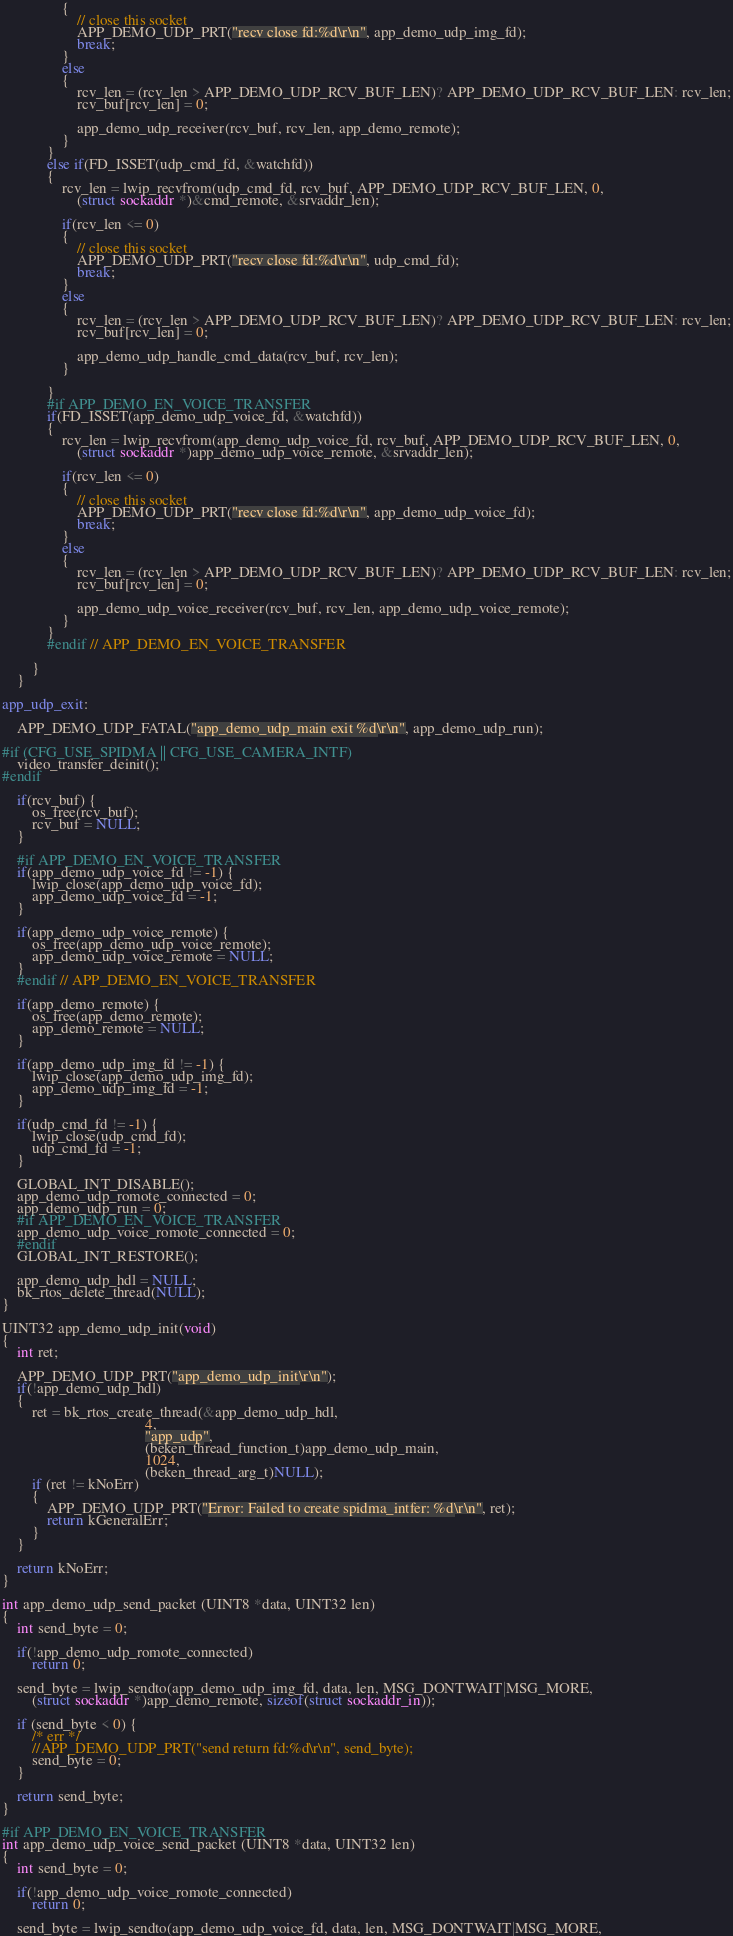Convert code to text. <code><loc_0><loc_0><loc_500><loc_500><_C_>                {
                    // close this socket
                    APP_DEMO_UDP_PRT("recv close fd:%d\r\n", app_demo_udp_img_fd);
                    break;
                } 
                else 
                {
                    rcv_len = (rcv_len > APP_DEMO_UDP_RCV_BUF_LEN)? APP_DEMO_UDP_RCV_BUF_LEN: rcv_len;
                    rcv_buf[rcv_len] = 0;

                    app_demo_udp_receiver(rcv_buf, rcv_len, app_demo_remote);
                }
            }
            else if(FD_ISSET(udp_cmd_fd, &watchfd)) 
            {
                rcv_len = lwip_recvfrom(udp_cmd_fd, rcv_buf, APP_DEMO_UDP_RCV_BUF_LEN, 0,
                    (struct sockaddr *)&cmd_remote, &srvaddr_len);
                
                if(rcv_len <= 0) 
                {
                    // close this socket
                    APP_DEMO_UDP_PRT("recv close fd:%d\r\n", udp_cmd_fd);
                    break;
                } 
                else 
                {
                    rcv_len = (rcv_len > APP_DEMO_UDP_RCV_BUF_LEN)? APP_DEMO_UDP_RCV_BUF_LEN: rcv_len;
                    rcv_buf[rcv_len] = 0;
                    
                    app_demo_udp_handle_cmd_data(rcv_buf, rcv_len);
                }

            }
            #if APP_DEMO_EN_VOICE_TRANSFER
            if(FD_ISSET(app_demo_udp_voice_fd, &watchfd)) 
            { 
                rcv_len = lwip_recvfrom(app_demo_udp_voice_fd, rcv_buf, APP_DEMO_UDP_RCV_BUF_LEN, 0,
                    (struct sockaddr *)app_demo_udp_voice_remote, &srvaddr_len);
                
                if(rcv_len <= 0) 
                {
                    // close this socket
                    APP_DEMO_UDP_PRT("recv close fd:%d\r\n", app_demo_udp_voice_fd);
                    break;
                } 
                else 
                {
                    rcv_len = (rcv_len > APP_DEMO_UDP_RCV_BUF_LEN)? APP_DEMO_UDP_RCV_BUF_LEN: rcv_len;
                    rcv_buf[rcv_len] = 0;

                    app_demo_udp_voice_receiver(rcv_buf, rcv_len, app_demo_udp_voice_remote);
                }
            }
            #endif // APP_DEMO_EN_VOICE_TRANSFER

        }
    }
	
app_udp_exit:
    
    APP_DEMO_UDP_FATAL("app_demo_udp_main exit %d\r\n", app_demo_udp_run);

#if (CFG_USE_SPIDMA || CFG_USE_CAMERA_INTF)
    video_transfer_deinit();
#endif

    if(rcv_buf) {
        os_free(rcv_buf);
        rcv_buf = NULL;
    }

    #if APP_DEMO_EN_VOICE_TRANSFER
    if(app_demo_udp_voice_fd != -1) {
        lwip_close(app_demo_udp_voice_fd);
        app_demo_udp_voice_fd = -1;
    }
    
    if(app_demo_udp_voice_remote) {
        os_free(app_demo_udp_voice_remote);
        app_demo_udp_voice_remote = NULL;
    }
    #endif // APP_DEMO_EN_VOICE_TRANSFER
	
    if(app_demo_remote) {
        os_free(app_demo_remote);
        app_demo_remote = NULL;
    }
    
    if(app_demo_udp_img_fd != -1) {
        lwip_close(app_demo_udp_img_fd);
        app_demo_udp_img_fd = -1;
    }

    if(udp_cmd_fd != -1) {
        lwip_close(udp_cmd_fd);
        udp_cmd_fd = -1;
    }    

    GLOBAL_INT_DISABLE();
    app_demo_udp_romote_connected = 0;
    app_demo_udp_run = 0;
    #if APP_DEMO_EN_VOICE_TRANSFER
    app_demo_udp_voice_romote_connected = 0;
    #endif
    GLOBAL_INT_RESTORE(); 

    app_demo_udp_hdl = NULL;
    bk_rtos_delete_thread(NULL);
}

UINT32 app_demo_udp_init(void)
{
    int ret;

    APP_DEMO_UDP_PRT("app_demo_udp_init\r\n");
    if(!app_demo_udp_hdl)
    {
        ret = bk_rtos_create_thread(&app_demo_udp_hdl,
                                      4,
                                      "app_udp",
                                      (beken_thread_function_t)app_demo_udp_main,
                                      1024,
                                      (beken_thread_arg_t)NULL);
        if (ret != kNoErr)
        {
            APP_DEMO_UDP_PRT("Error: Failed to create spidma_intfer: %d\r\n", ret);
            return kGeneralErr;
        }
    }

    return kNoErr;
}

int app_demo_udp_send_packet (UINT8 *data, UINT32 len)
{
    int send_byte = 0;

    if(!app_demo_udp_romote_connected)
        return 0;

    send_byte = lwip_sendto(app_demo_udp_img_fd, data, len, MSG_DONTWAIT|MSG_MORE,
        (struct sockaddr *)app_demo_remote, sizeof(struct sockaddr_in));
    
    if (send_byte < 0) {
        /* err */
        //APP_DEMO_UDP_PRT("send return fd:%d\r\n", send_byte);
        send_byte = 0;
    }

	return send_byte;
}

#if APP_DEMO_EN_VOICE_TRANSFER
int app_demo_udp_voice_send_packet (UINT8 *data, UINT32 len)
{
    int send_byte = 0;

    if(!app_demo_udp_voice_romote_connected)
        return 0;

    send_byte = lwip_sendto(app_demo_udp_voice_fd, data, len, MSG_DONTWAIT|MSG_MORE,</code> 